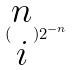<formula> <loc_0><loc_0><loc_500><loc_500>( \begin{matrix} n \\ i \end{matrix} ) 2 ^ { - n }</formula> 